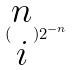<formula> <loc_0><loc_0><loc_500><loc_500>( \begin{matrix} n \\ i \end{matrix} ) 2 ^ { - n }</formula> 